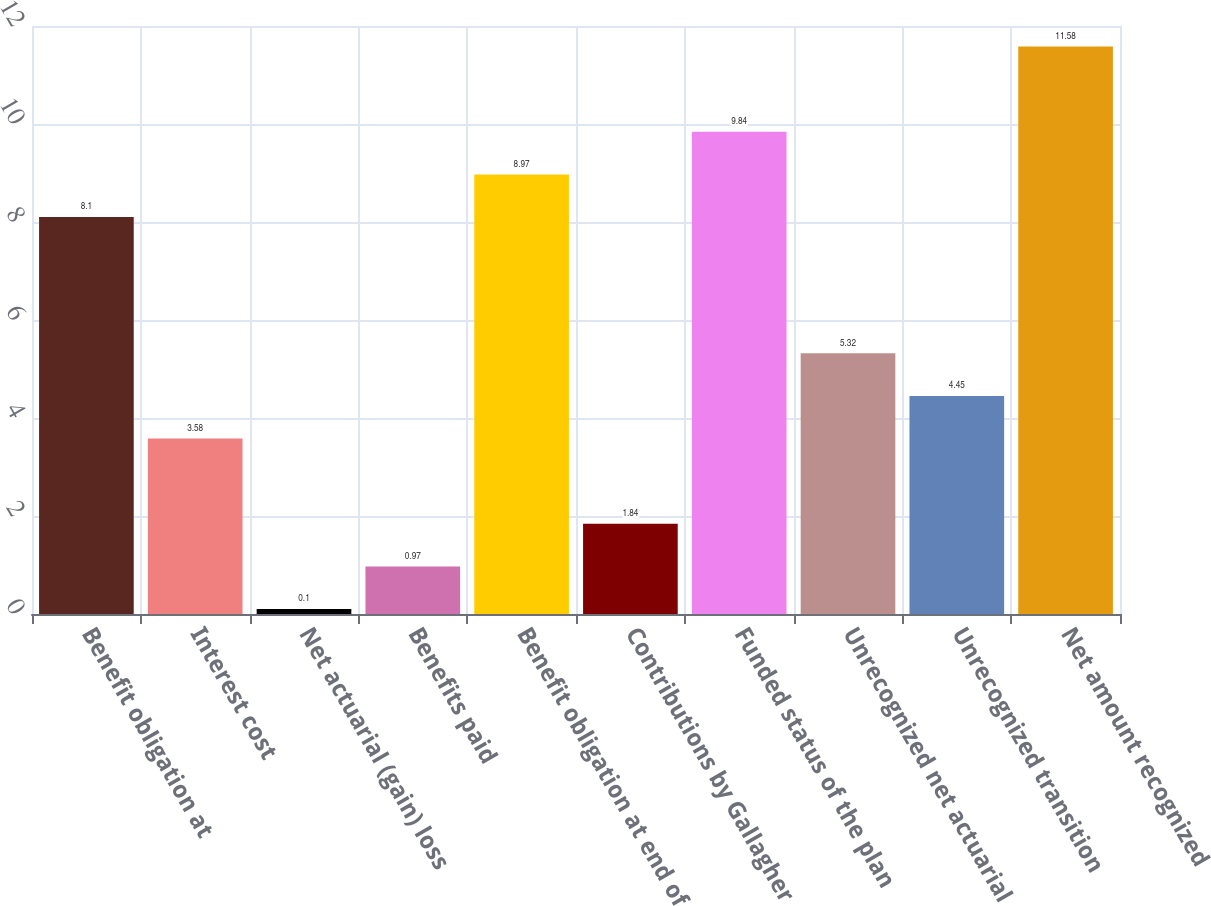<chart> <loc_0><loc_0><loc_500><loc_500><bar_chart><fcel>Benefit obligation at<fcel>Interest cost<fcel>Net actuarial (gain) loss<fcel>Benefits paid<fcel>Benefit obligation at end of<fcel>Contributions by Gallagher<fcel>Funded status of the plan<fcel>Unrecognized net actuarial<fcel>Unrecognized transition<fcel>Net amount recognized<nl><fcel>8.1<fcel>3.58<fcel>0.1<fcel>0.97<fcel>8.97<fcel>1.84<fcel>9.84<fcel>5.32<fcel>4.45<fcel>11.58<nl></chart> 